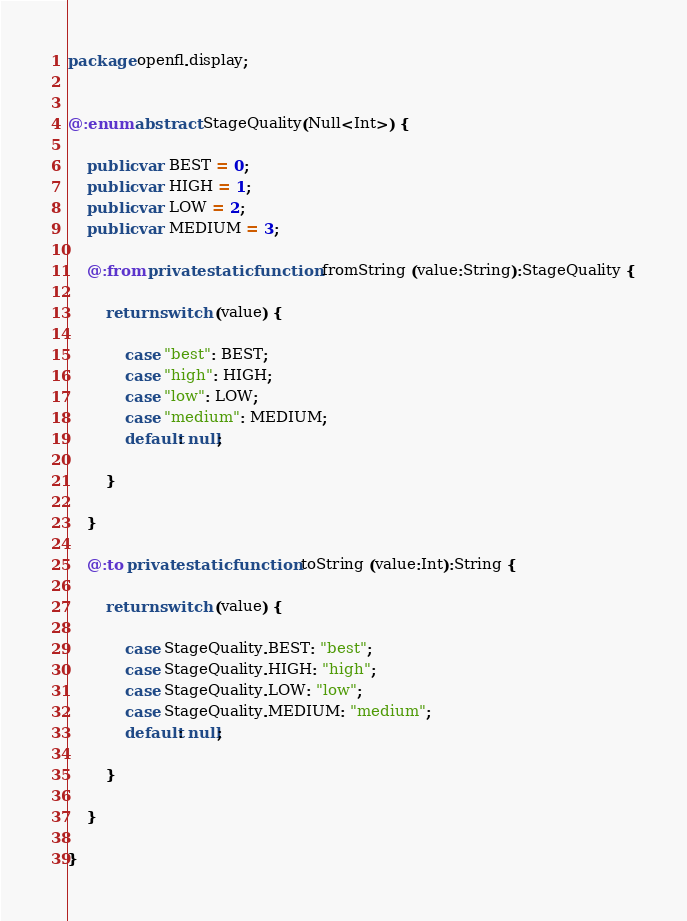<code> <loc_0><loc_0><loc_500><loc_500><_Haxe_>package openfl.display;


@:enum abstract StageQuality(Null<Int>) {
	
	public var BEST = 0;
	public var HIGH = 1;
	public var LOW = 2;
	public var MEDIUM = 3;
	
	@:from private static function fromString (value:String):StageQuality {
		
		return switch (value) {
			
			case "best": BEST;
			case "high": HIGH;
			case "low": LOW;
			case "medium": MEDIUM;
			default: null;
			
		}
		
	}
	
	@:to private static function toString (value:Int):String {
		
		return switch (value) {
			
			case StageQuality.BEST: "best";
			case StageQuality.HIGH: "high";
			case StageQuality.LOW: "low";
			case StageQuality.MEDIUM: "medium";
			default: null;
			
		}
		
	}
	
}</code> 